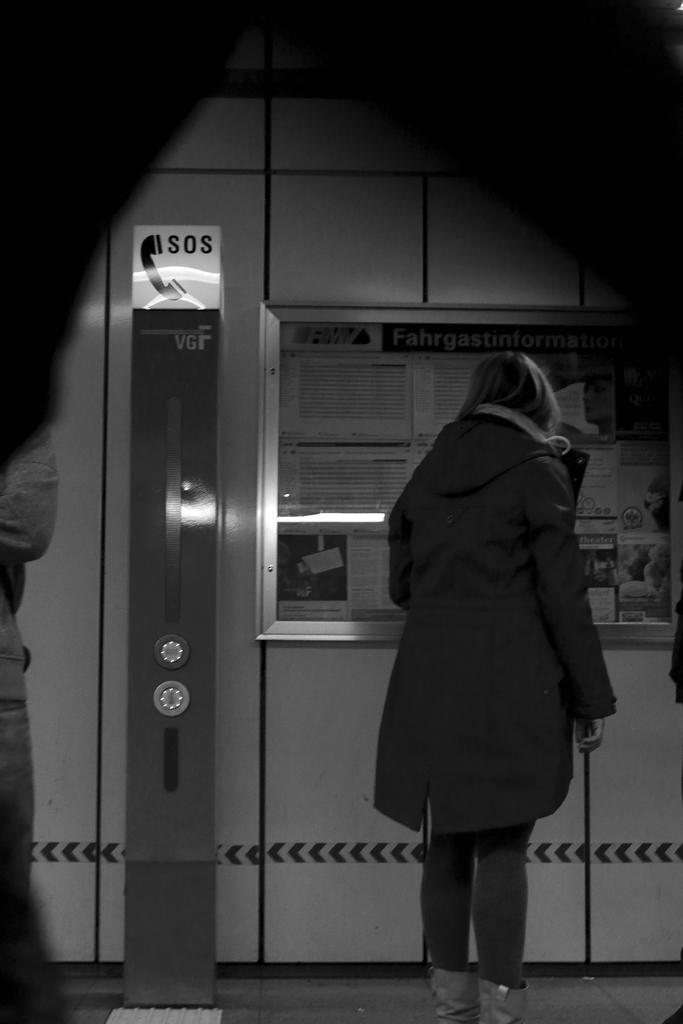<image>
Create a compact narrative representing the image presented. A sign that says SOS has a black image of a phone on it. 